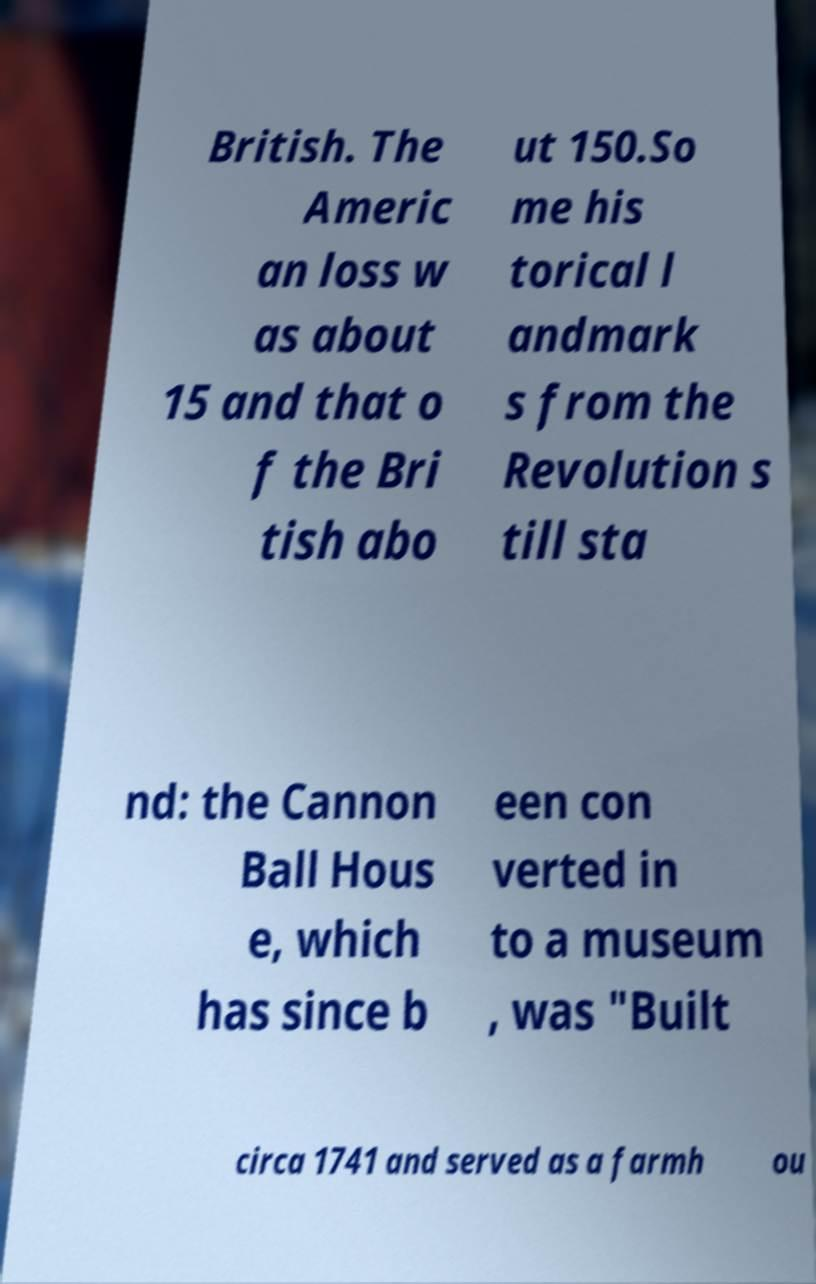Can you accurately transcribe the text from the provided image for me? British. The Americ an loss w as about 15 and that o f the Bri tish abo ut 150.So me his torical l andmark s from the Revolution s till sta nd: the Cannon Ball Hous e, which has since b een con verted in to a museum , was "Built circa 1741 and served as a farmh ou 